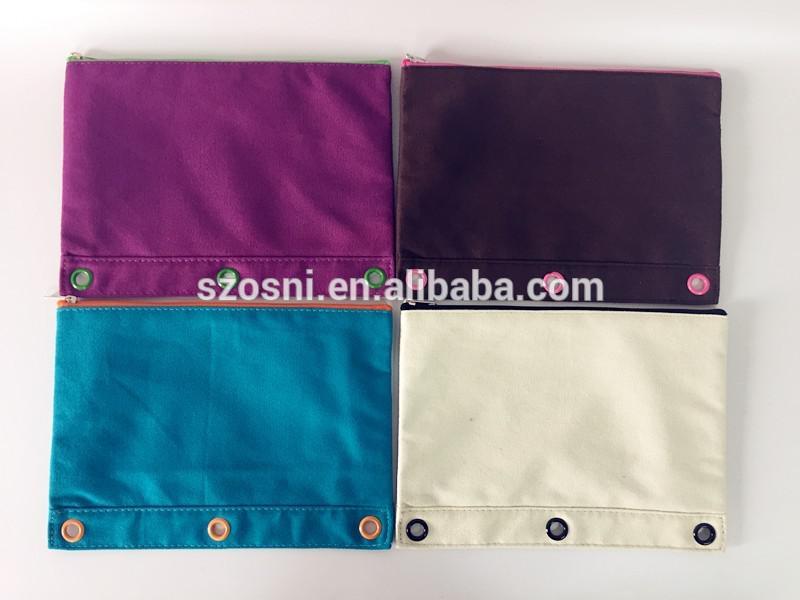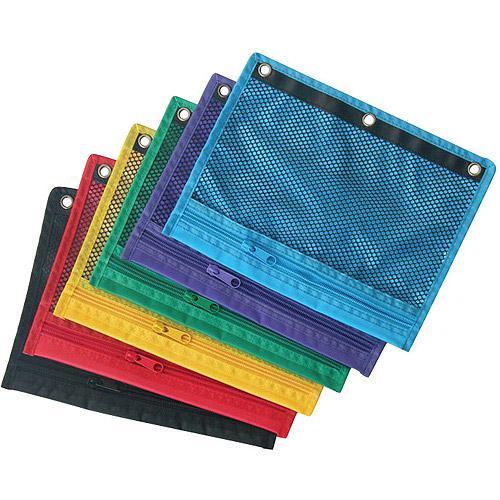The first image is the image on the left, the second image is the image on the right. For the images shown, is this caption "There are three pencil cases in the right image." true? Answer yes or no. No. The first image is the image on the left, the second image is the image on the right. Considering the images on both sides, is "An image shows at least five different solid-colored pencil cases with eyelets on one edge." valid? Answer yes or no. Yes. 